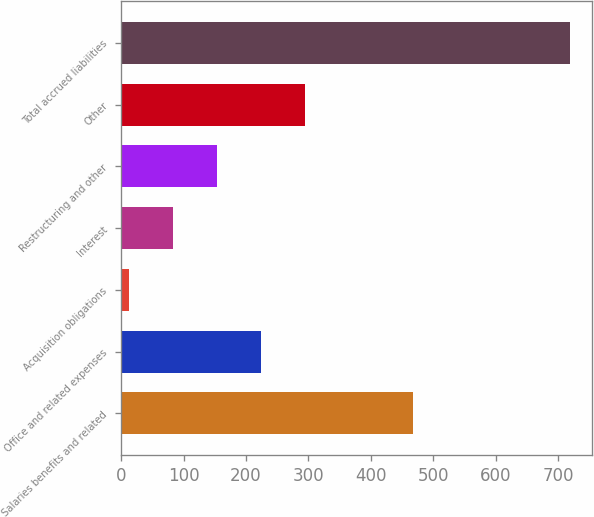Convert chart. <chart><loc_0><loc_0><loc_500><loc_500><bar_chart><fcel>Salaries benefits and related<fcel>Office and related expenses<fcel>Acquisition obligations<fcel>Interest<fcel>Restructuring and other<fcel>Other<fcel>Total accrued liabilities<nl><fcel>467.2<fcel>224.48<fcel>12.8<fcel>83.36<fcel>153.92<fcel>295.04<fcel>718.4<nl></chart> 